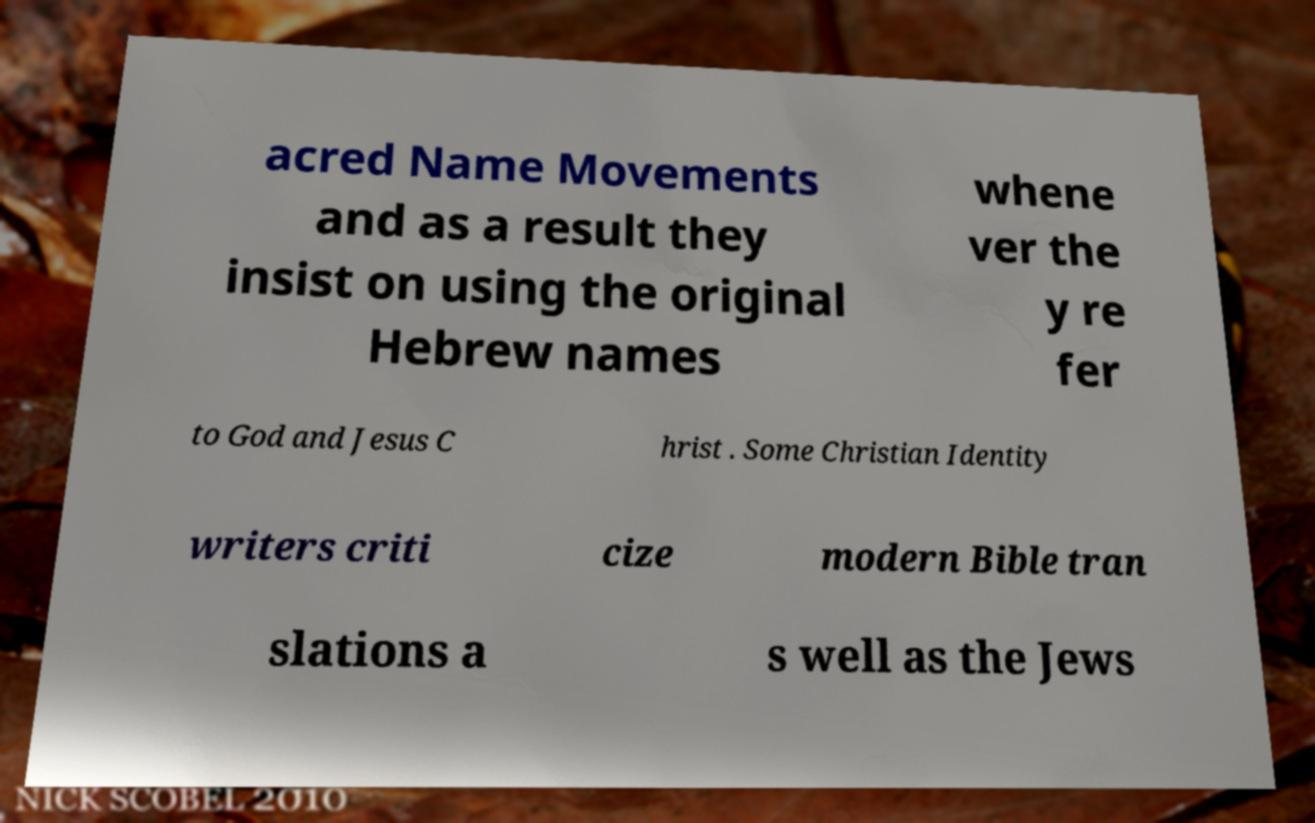Can you accurately transcribe the text from the provided image for me? acred Name Movements and as a result they insist on using the original Hebrew names whene ver the y re fer to God and Jesus C hrist . Some Christian Identity writers criti cize modern Bible tran slations a s well as the Jews 